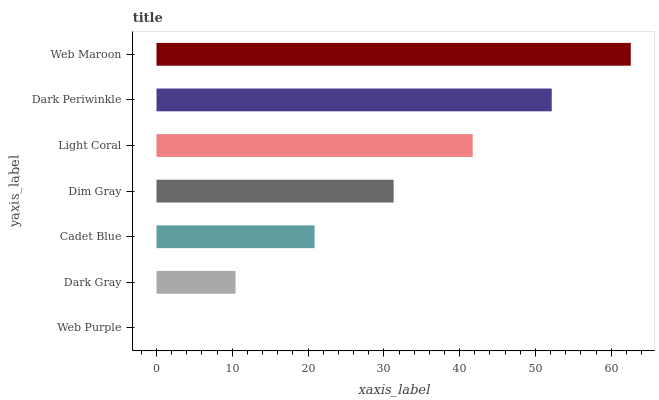Is Web Purple the minimum?
Answer yes or no. Yes. Is Web Maroon the maximum?
Answer yes or no. Yes. Is Dark Gray the minimum?
Answer yes or no. No. Is Dark Gray the maximum?
Answer yes or no. No. Is Dark Gray greater than Web Purple?
Answer yes or no. Yes. Is Web Purple less than Dark Gray?
Answer yes or no. Yes. Is Web Purple greater than Dark Gray?
Answer yes or no. No. Is Dark Gray less than Web Purple?
Answer yes or no. No. Is Dim Gray the high median?
Answer yes or no. Yes. Is Dim Gray the low median?
Answer yes or no. Yes. Is Dark Periwinkle the high median?
Answer yes or no. No. Is Web Purple the low median?
Answer yes or no. No. 